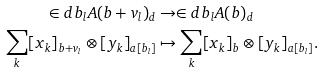<formula> <loc_0><loc_0><loc_500><loc_500>\in d { b _ { l } } A ( b + v _ { l } ) _ { d } & \to \in d { b _ { l } } A ( b ) _ { d } \\ \sum _ { k } [ x _ { k } ] _ { b + v _ { l } } \otimes [ y _ { k } ] _ { a [ b _ { l } ] } & \mapsto \sum _ { k } [ x _ { k } ] _ { b } \otimes [ y _ { k } ] _ { a [ b _ { l } ] } .</formula> 